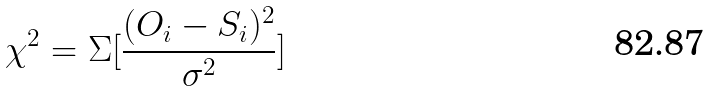Convert formula to latex. <formula><loc_0><loc_0><loc_500><loc_500>\chi ^ { 2 } = \Sigma [ \frac { ( O _ { i } - S _ { i } ) ^ { 2 } } { \sigma ^ { 2 } } ]</formula> 